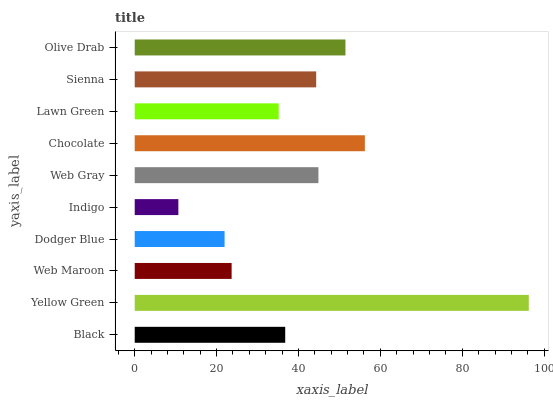Is Indigo the minimum?
Answer yes or no. Yes. Is Yellow Green the maximum?
Answer yes or no. Yes. Is Web Maroon the minimum?
Answer yes or no. No. Is Web Maroon the maximum?
Answer yes or no. No. Is Yellow Green greater than Web Maroon?
Answer yes or no. Yes. Is Web Maroon less than Yellow Green?
Answer yes or no. Yes. Is Web Maroon greater than Yellow Green?
Answer yes or no. No. Is Yellow Green less than Web Maroon?
Answer yes or no. No. Is Sienna the high median?
Answer yes or no. Yes. Is Black the low median?
Answer yes or no. Yes. Is Lawn Green the high median?
Answer yes or no. No. Is Yellow Green the low median?
Answer yes or no. No. 